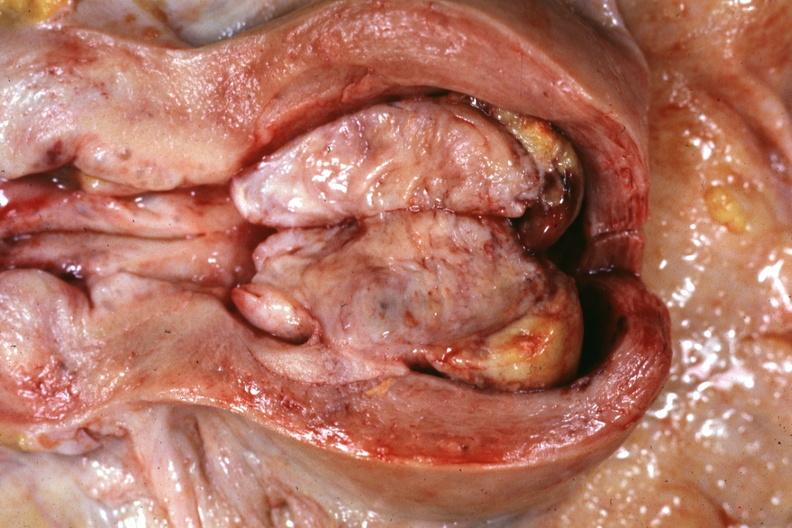s opened muscle present?
Answer the question using a single word or phrase. No 